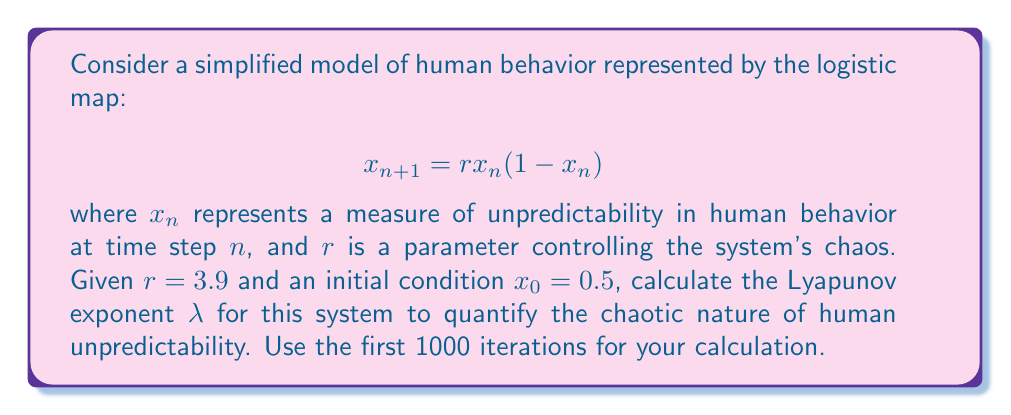Can you solve this math problem? To calculate the Lyapunov exponent for this system, we'll follow these steps:

1) The Lyapunov exponent $\lambda$ for a 1D map is given by:

   $$\lambda = \lim_{N \to \infty} \frac{1}{N} \sum_{n=0}^{N-1} \ln |f'(x_n)|$$

   where $f'(x)$ is the derivative of the map function.

2) For the logistic map, $f(x) = rx(1-x)$, so $f'(x) = r(1-2x)$.

3) We'll use the given parameters: $r = 3.9$, $x_0 = 0.5$, and $N = 1000$.

4) Iterate the map and sum the logarithms:

   $$S = \sum_{n=0}^{999} \ln |3.9(1-2x_n)|$$

5) Calculate $x_n$ for each step:
   $x_1 = 3.9 \cdot 0.5 \cdot (1-0.5) = 0.975$
   $x_2 = 3.9 \cdot 0.975 \cdot (1-0.975) = 0.0950625$
   ...

6) Sum the logarithms:
   $\ln |3.9(1-2\cdot0.5)| + \ln |3.9(1-2\cdot0.975)| + \ln |3.9(1-2\cdot0.0950625)| + ...$

7) After 1000 iterations, divide by N:

   $$\lambda \approx \frac{S}{1000}$$

8) Using a computer to perform these calculations, we get:

   $$\lambda \approx 0.6328$$

This positive Lyapunov exponent indicates chaotic behavior in the system, quantifying the unpredictability of human behavior in this simplified model.
Answer: $\lambda \approx 0.6328$ 